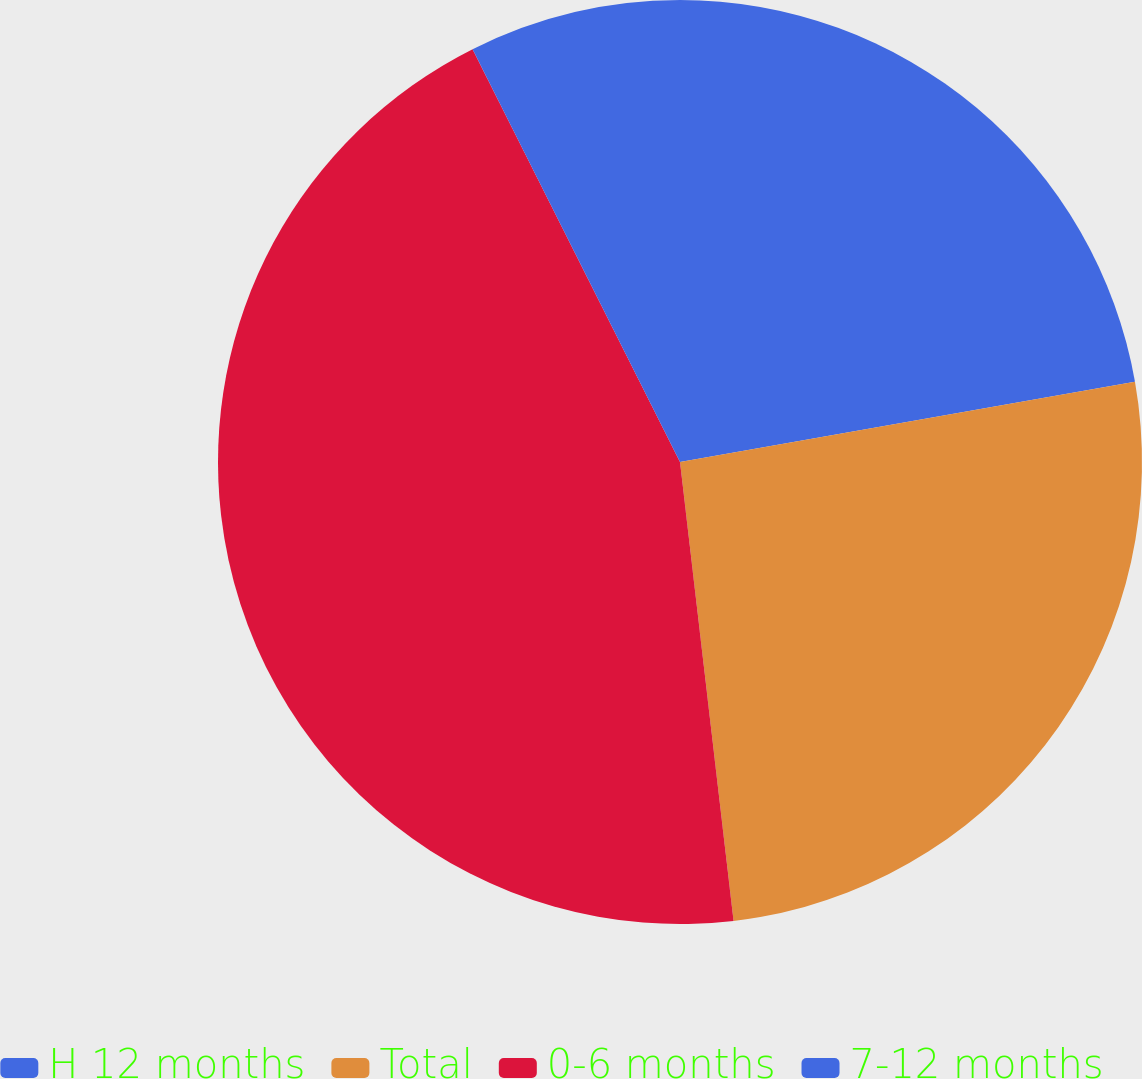<chart> <loc_0><loc_0><loc_500><loc_500><pie_chart><fcel>H 12 months<fcel>Total<fcel>0-6 months<fcel>7-12 months<nl><fcel>22.22%<fcel>25.93%<fcel>44.44%<fcel>7.41%<nl></chart> 